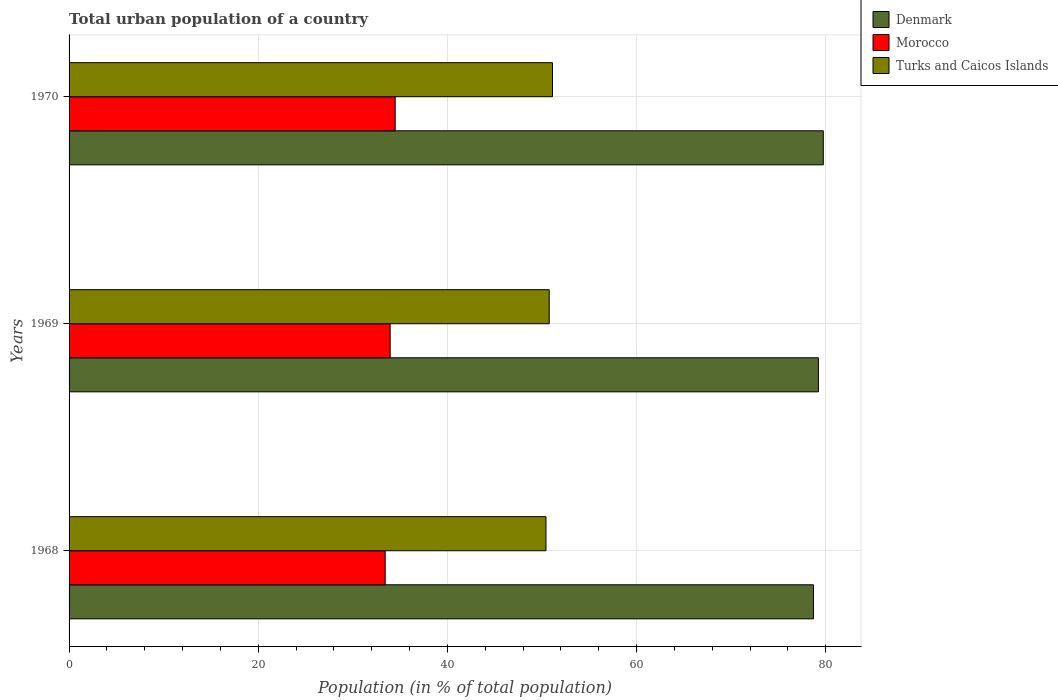Are the number of bars per tick equal to the number of legend labels?
Your answer should be very brief. Yes. How many bars are there on the 1st tick from the top?
Provide a succinct answer. 3. How many bars are there on the 2nd tick from the bottom?
Make the answer very short. 3. What is the label of the 2nd group of bars from the top?
Provide a succinct answer. 1969. In how many cases, is the number of bars for a given year not equal to the number of legend labels?
Make the answer very short. 0. What is the urban population in Turks and Caicos Islands in 1970?
Ensure brevity in your answer.  51.11. Across all years, what is the maximum urban population in Morocco?
Your response must be concise. 34.48. Across all years, what is the minimum urban population in Denmark?
Provide a short and direct response. 78.7. In which year was the urban population in Morocco minimum?
Provide a short and direct response. 1968. What is the total urban population in Morocco in the graph?
Your answer should be very brief. 101.84. What is the difference between the urban population in Turks and Caicos Islands in 1969 and that in 1970?
Make the answer very short. -0.34. What is the difference between the urban population in Denmark in 1969 and the urban population in Turks and Caicos Islands in 1968?
Give a very brief answer. 28.8. What is the average urban population in Morocco per year?
Your answer should be compact. 33.95. In the year 1969, what is the difference between the urban population in Turks and Caicos Islands and urban population in Morocco?
Make the answer very short. 16.82. In how many years, is the urban population in Denmark greater than 20 %?
Ensure brevity in your answer.  3. What is the ratio of the urban population in Morocco in 1968 to that in 1970?
Provide a succinct answer. 0.97. What is the difference between the highest and the second highest urban population in Turks and Caicos Islands?
Your answer should be very brief. 0.34. What is the difference between the highest and the lowest urban population in Turks and Caicos Islands?
Give a very brief answer. 0.69. What does the 1st bar from the top in 1969 represents?
Your answer should be very brief. Turks and Caicos Islands. What does the 3rd bar from the bottom in 1970 represents?
Offer a very short reply. Turks and Caicos Islands. Are the values on the major ticks of X-axis written in scientific E-notation?
Provide a succinct answer. No. Does the graph contain any zero values?
Your answer should be very brief. No. Does the graph contain grids?
Give a very brief answer. Yes. Where does the legend appear in the graph?
Your response must be concise. Top right. How many legend labels are there?
Your response must be concise. 3. How are the legend labels stacked?
Your answer should be very brief. Vertical. What is the title of the graph?
Make the answer very short. Total urban population of a country. Does "Serbia" appear as one of the legend labels in the graph?
Your response must be concise. No. What is the label or title of the X-axis?
Keep it short and to the point. Population (in % of total population). What is the Population (in % of total population) in Denmark in 1968?
Offer a very short reply. 78.7. What is the Population (in % of total population) in Morocco in 1968?
Offer a terse response. 33.42. What is the Population (in % of total population) in Turks and Caicos Islands in 1968?
Your answer should be compact. 50.42. What is the Population (in % of total population) of Denmark in 1969?
Give a very brief answer. 79.22. What is the Population (in % of total population) in Morocco in 1969?
Your response must be concise. 33.95. What is the Population (in % of total population) in Turks and Caicos Islands in 1969?
Your response must be concise. 50.76. What is the Population (in % of total population) in Denmark in 1970?
Your answer should be compact. 79.74. What is the Population (in % of total population) of Morocco in 1970?
Give a very brief answer. 34.48. What is the Population (in % of total population) in Turks and Caicos Islands in 1970?
Provide a short and direct response. 51.11. Across all years, what is the maximum Population (in % of total population) of Denmark?
Provide a short and direct response. 79.74. Across all years, what is the maximum Population (in % of total population) in Morocco?
Offer a very short reply. 34.48. Across all years, what is the maximum Population (in % of total population) of Turks and Caicos Islands?
Ensure brevity in your answer.  51.11. Across all years, what is the minimum Population (in % of total population) in Denmark?
Ensure brevity in your answer.  78.7. Across all years, what is the minimum Population (in % of total population) of Morocco?
Give a very brief answer. 33.42. Across all years, what is the minimum Population (in % of total population) in Turks and Caicos Islands?
Provide a short and direct response. 50.42. What is the total Population (in % of total population) of Denmark in the graph?
Provide a succinct answer. 237.66. What is the total Population (in % of total population) of Morocco in the graph?
Ensure brevity in your answer.  101.84. What is the total Population (in % of total population) in Turks and Caicos Islands in the graph?
Your answer should be compact. 152.29. What is the difference between the Population (in % of total population) of Denmark in 1968 and that in 1969?
Your response must be concise. -0.52. What is the difference between the Population (in % of total population) in Morocco in 1968 and that in 1969?
Provide a short and direct response. -0.53. What is the difference between the Population (in % of total population) of Turks and Caicos Islands in 1968 and that in 1969?
Give a very brief answer. -0.34. What is the difference between the Population (in % of total population) in Denmark in 1968 and that in 1970?
Make the answer very short. -1.04. What is the difference between the Population (in % of total population) of Morocco in 1968 and that in 1970?
Provide a short and direct response. -1.06. What is the difference between the Population (in % of total population) in Turks and Caicos Islands in 1968 and that in 1970?
Ensure brevity in your answer.  -0.69. What is the difference between the Population (in % of total population) in Denmark in 1969 and that in 1970?
Your answer should be very brief. -0.52. What is the difference between the Population (in % of total population) of Morocco in 1969 and that in 1970?
Offer a terse response. -0.53. What is the difference between the Population (in % of total population) in Turks and Caicos Islands in 1969 and that in 1970?
Offer a very short reply. -0.34. What is the difference between the Population (in % of total population) in Denmark in 1968 and the Population (in % of total population) in Morocco in 1969?
Offer a very short reply. 44.75. What is the difference between the Population (in % of total population) of Denmark in 1968 and the Population (in % of total population) of Turks and Caicos Islands in 1969?
Ensure brevity in your answer.  27.93. What is the difference between the Population (in % of total population) of Morocco in 1968 and the Population (in % of total population) of Turks and Caicos Islands in 1969?
Ensure brevity in your answer.  -17.34. What is the difference between the Population (in % of total population) of Denmark in 1968 and the Population (in % of total population) of Morocco in 1970?
Give a very brief answer. 44.22. What is the difference between the Population (in % of total population) in Denmark in 1968 and the Population (in % of total population) in Turks and Caicos Islands in 1970?
Provide a short and direct response. 27.59. What is the difference between the Population (in % of total population) of Morocco in 1968 and the Population (in % of total population) of Turks and Caicos Islands in 1970?
Give a very brief answer. -17.69. What is the difference between the Population (in % of total population) in Denmark in 1969 and the Population (in % of total population) in Morocco in 1970?
Keep it short and to the point. 44.74. What is the difference between the Population (in % of total population) in Denmark in 1969 and the Population (in % of total population) in Turks and Caicos Islands in 1970?
Your answer should be very brief. 28.12. What is the difference between the Population (in % of total population) in Morocco in 1969 and the Population (in % of total population) in Turks and Caicos Islands in 1970?
Offer a terse response. -17.16. What is the average Population (in % of total population) in Denmark per year?
Your answer should be compact. 79.22. What is the average Population (in % of total population) of Morocco per year?
Provide a short and direct response. 33.95. What is the average Population (in % of total population) of Turks and Caicos Islands per year?
Provide a succinct answer. 50.76. In the year 1968, what is the difference between the Population (in % of total population) of Denmark and Population (in % of total population) of Morocco?
Make the answer very short. 45.28. In the year 1968, what is the difference between the Population (in % of total population) in Denmark and Population (in % of total population) in Turks and Caicos Islands?
Keep it short and to the point. 28.28. In the year 1968, what is the difference between the Population (in % of total population) in Morocco and Population (in % of total population) in Turks and Caicos Islands?
Provide a succinct answer. -17. In the year 1969, what is the difference between the Population (in % of total population) of Denmark and Population (in % of total population) of Morocco?
Offer a terse response. 45.28. In the year 1969, what is the difference between the Population (in % of total population) in Denmark and Population (in % of total population) in Turks and Caicos Islands?
Ensure brevity in your answer.  28.46. In the year 1969, what is the difference between the Population (in % of total population) in Morocco and Population (in % of total population) in Turks and Caicos Islands?
Ensure brevity in your answer.  -16.82. In the year 1970, what is the difference between the Population (in % of total population) in Denmark and Population (in % of total population) in Morocco?
Ensure brevity in your answer.  45.26. In the year 1970, what is the difference between the Population (in % of total population) in Denmark and Population (in % of total population) in Turks and Caicos Islands?
Provide a succinct answer. 28.63. In the year 1970, what is the difference between the Population (in % of total population) in Morocco and Population (in % of total population) in Turks and Caicos Islands?
Make the answer very short. -16.63. What is the ratio of the Population (in % of total population) of Morocco in 1968 to that in 1969?
Provide a short and direct response. 0.98. What is the ratio of the Population (in % of total population) in Turks and Caicos Islands in 1968 to that in 1969?
Provide a short and direct response. 0.99. What is the ratio of the Population (in % of total population) in Morocco in 1968 to that in 1970?
Make the answer very short. 0.97. What is the ratio of the Population (in % of total population) in Turks and Caicos Islands in 1968 to that in 1970?
Keep it short and to the point. 0.99. What is the ratio of the Population (in % of total population) in Denmark in 1969 to that in 1970?
Ensure brevity in your answer.  0.99. What is the ratio of the Population (in % of total population) in Morocco in 1969 to that in 1970?
Ensure brevity in your answer.  0.98. What is the ratio of the Population (in % of total population) in Turks and Caicos Islands in 1969 to that in 1970?
Make the answer very short. 0.99. What is the difference between the highest and the second highest Population (in % of total population) of Denmark?
Offer a terse response. 0.52. What is the difference between the highest and the second highest Population (in % of total population) in Morocco?
Offer a very short reply. 0.53. What is the difference between the highest and the second highest Population (in % of total population) of Turks and Caicos Islands?
Your response must be concise. 0.34. What is the difference between the highest and the lowest Population (in % of total population) of Denmark?
Your response must be concise. 1.04. What is the difference between the highest and the lowest Population (in % of total population) of Morocco?
Make the answer very short. 1.06. What is the difference between the highest and the lowest Population (in % of total population) of Turks and Caicos Islands?
Offer a very short reply. 0.69. 